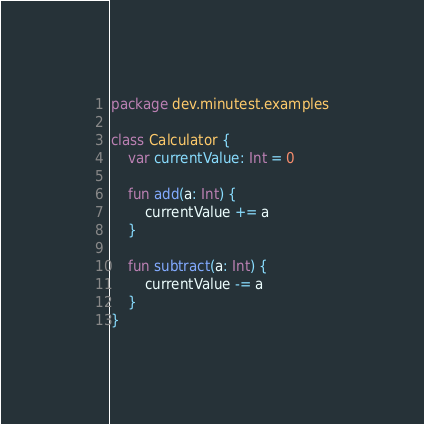<code> <loc_0><loc_0><loc_500><loc_500><_Kotlin_>package dev.minutest.examples

class Calculator {
    var currentValue: Int = 0

    fun add(a: Int) {
        currentValue += a
    }

    fun subtract(a: Int) {
        currentValue -= a
    }
}

</code> 